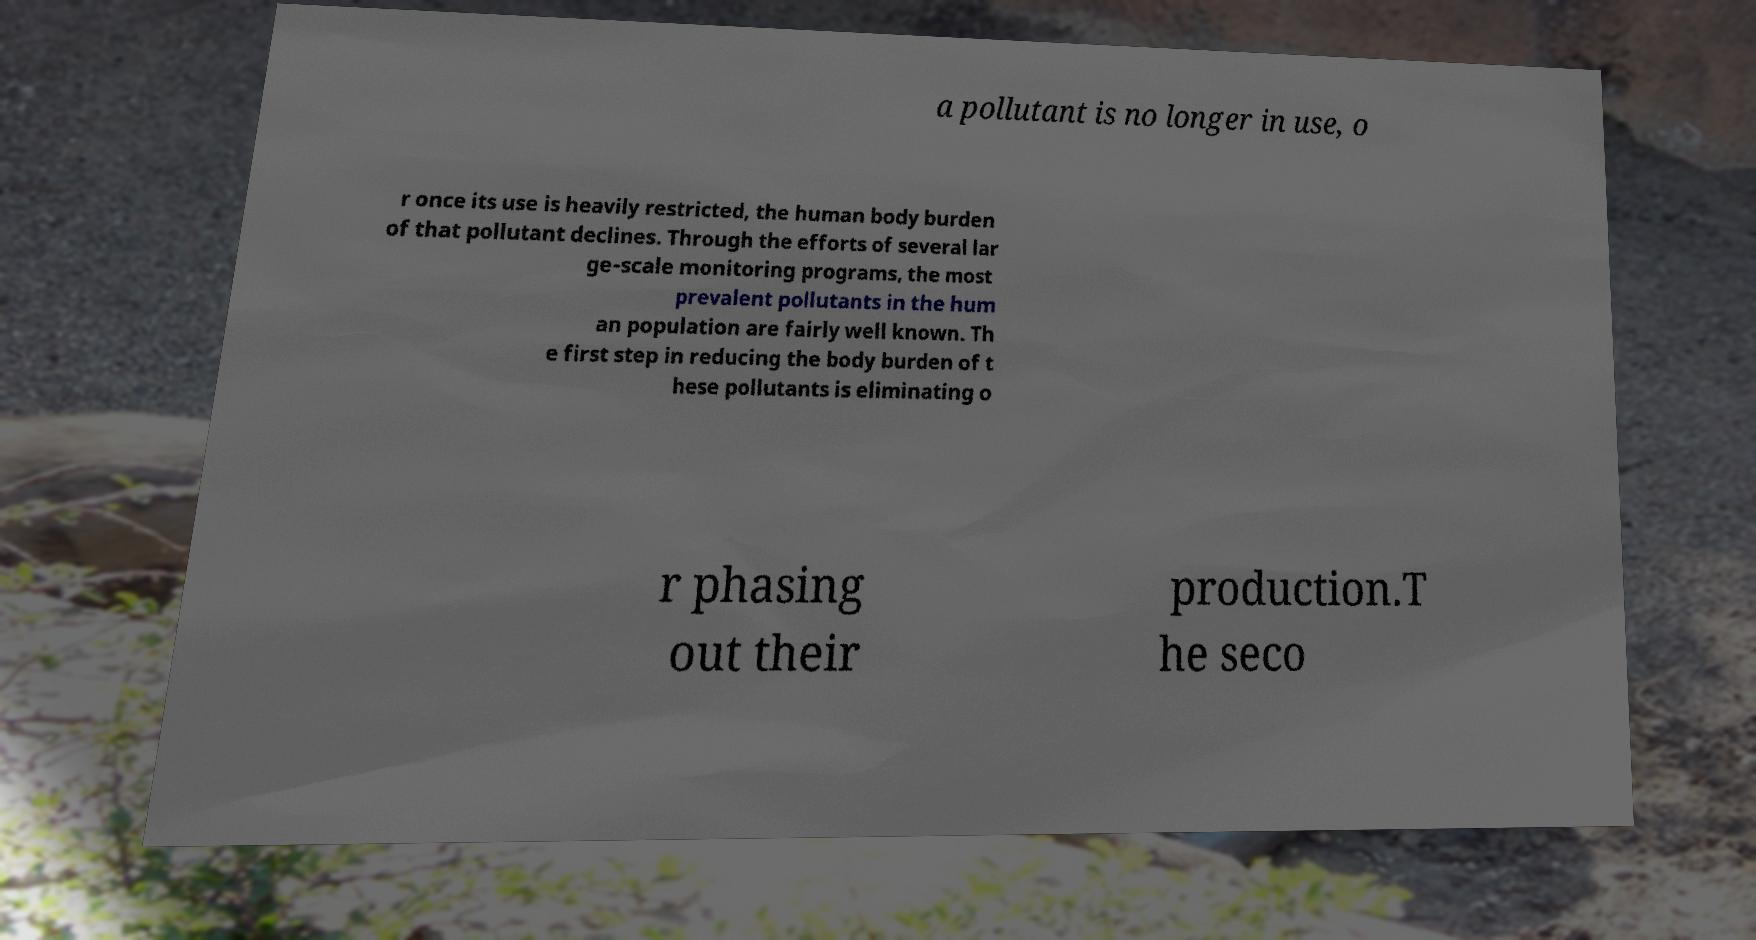Can you read and provide the text displayed in the image?This photo seems to have some interesting text. Can you extract and type it out for me? a pollutant is no longer in use, o r once its use is heavily restricted, the human body burden of that pollutant declines. Through the efforts of several lar ge-scale monitoring programs, the most prevalent pollutants in the hum an population are fairly well known. Th e first step in reducing the body burden of t hese pollutants is eliminating o r phasing out their production.T he seco 